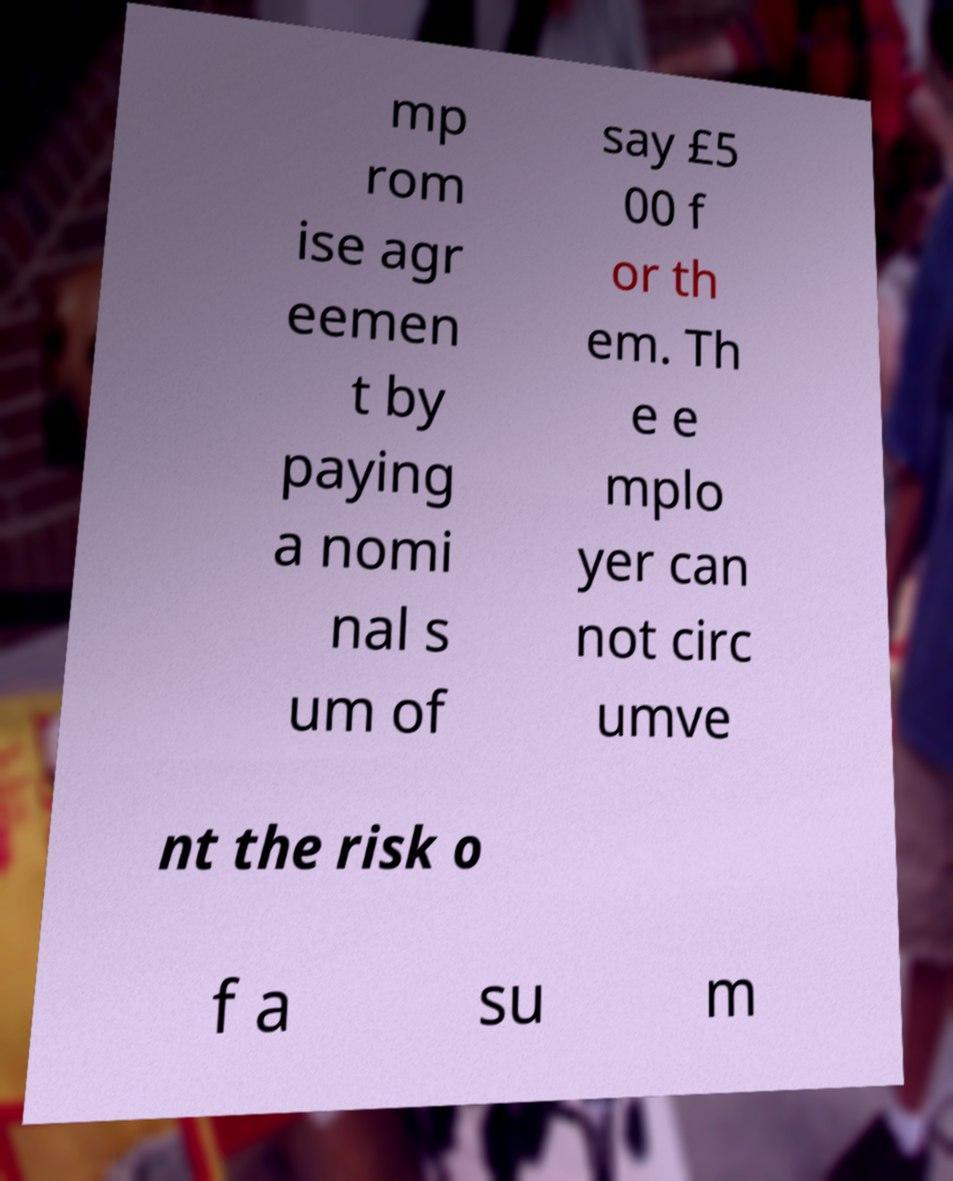Can you read and provide the text displayed in the image?This photo seems to have some interesting text. Can you extract and type it out for me? mp rom ise agr eemen t by paying a nomi nal s um of say £5 00 f or th em. Th e e mplo yer can not circ umve nt the risk o f a su m 